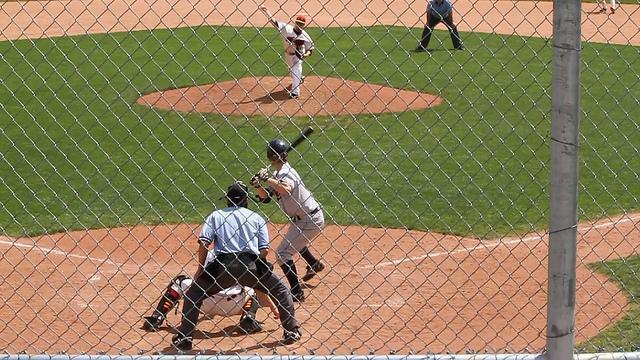The fence is placed in front of what part of the stadium to stop the pitchers fastball from hitting it?
Select the correct answer and articulate reasoning with the following format: 'Answer: answer
Rationale: rationale.'
Options: Fans, all correct, stands, audience. Answer: all correct.
Rationale: The fence is to protect the audience who sits in the stadium seats. 